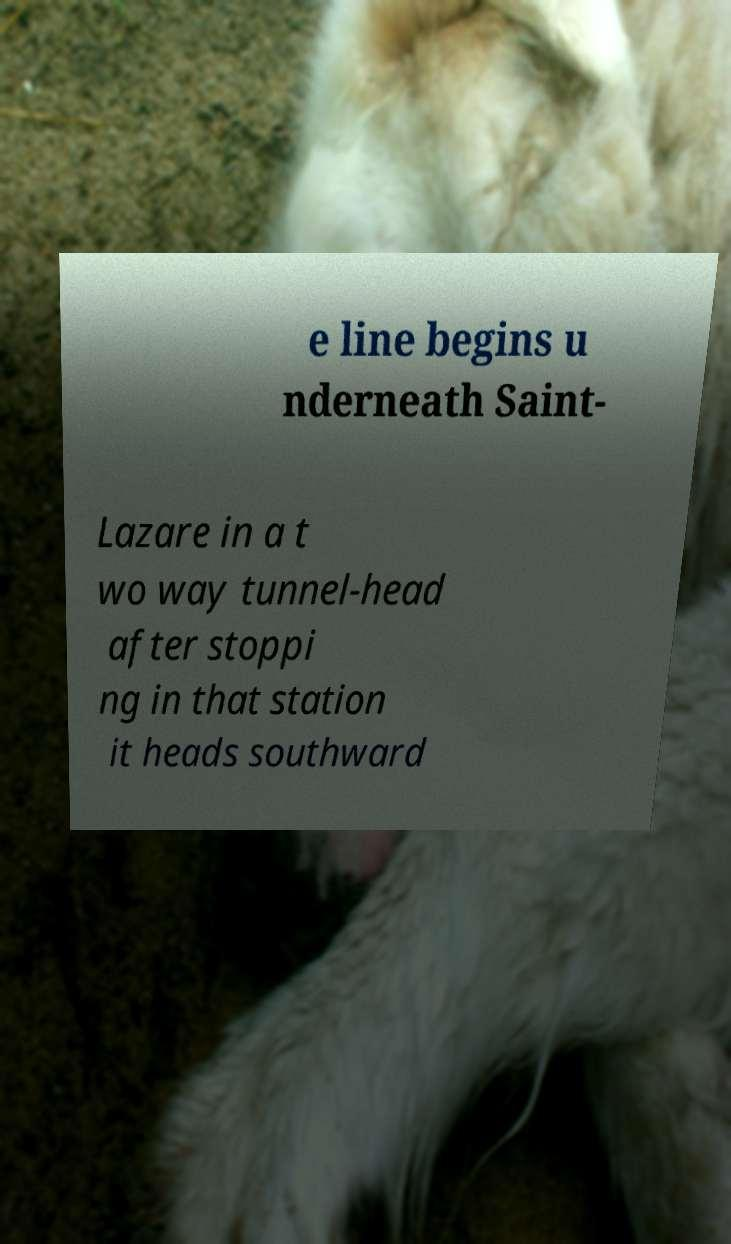Could you assist in decoding the text presented in this image and type it out clearly? e line begins u nderneath Saint- Lazare in a t wo way tunnel-head after stoppi ng in that station it heads southward 